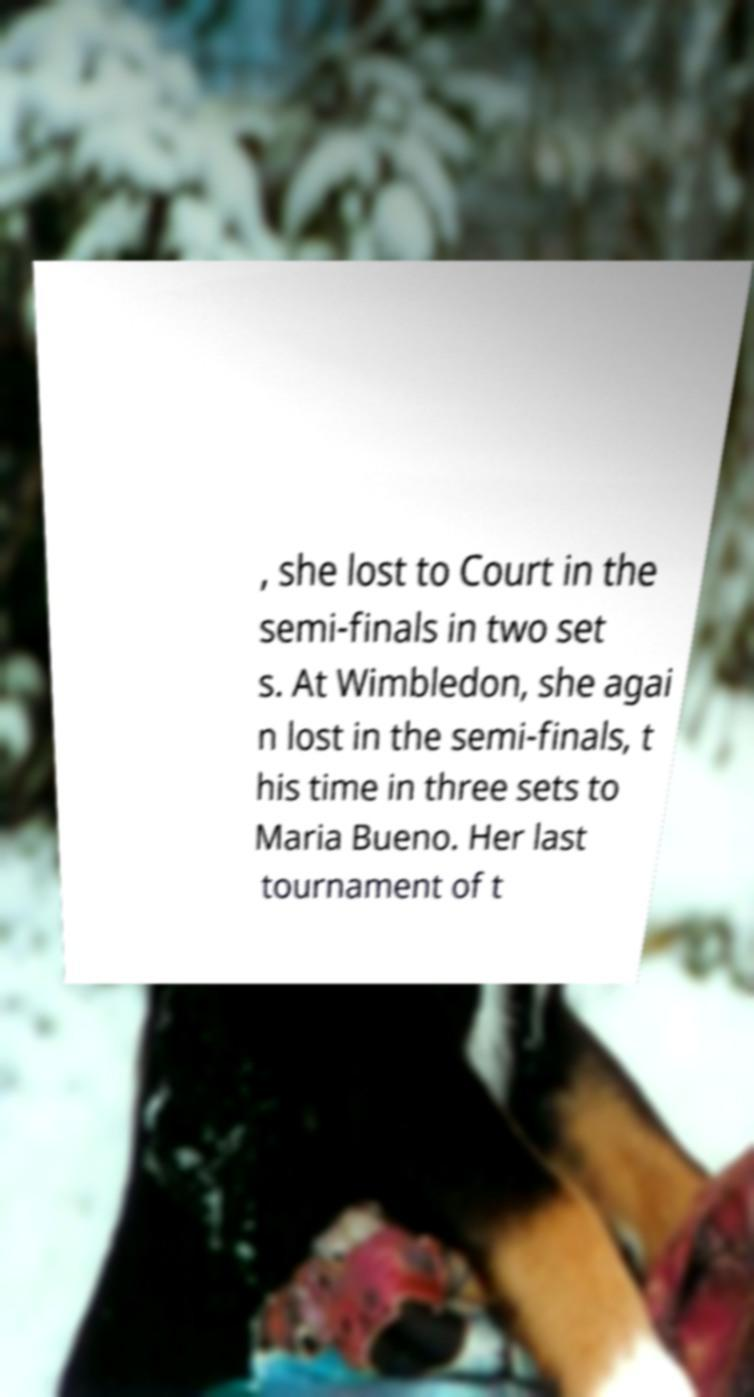What messages or text are displayed in this image? I need them in a readable, typed format. , she lost to Court in the semi-finals in two set s. At Wimbledon, she agai n lost in the semi-finals, t his time in three sets to Maria Bueno. Her last tournament of t 